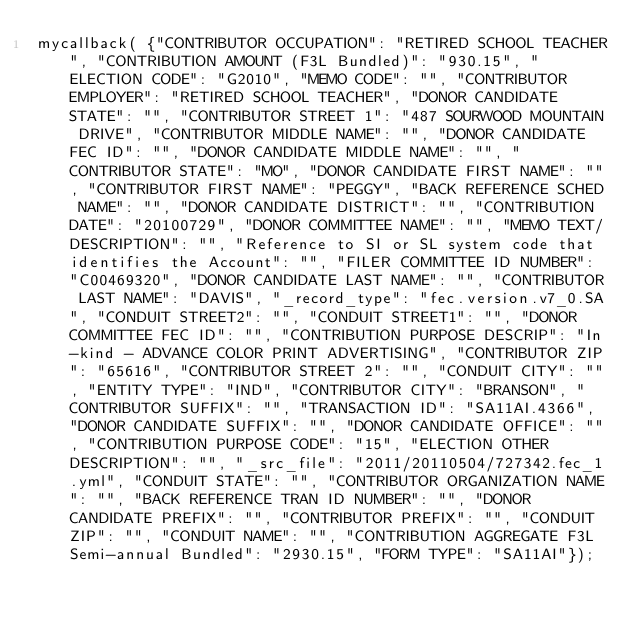<code> <loc_0><loc_0><loc_500><loc_500><_JavaScript_>mycallback( {"CONTRIBUTOR OCCUPATION": "RETIRED SCHOOL TEACHER", "CONTRIBUTION AMOUNT (F3L Bundled)": "930.15", "ELECTION CODE": "G2010", "MEMO CODE": "", "CONTRIBUTOR EMPLOYER": "RETIRED SCHOOL TEACHER", "DONOR CANDIDATE STATE": "", "CONTRIBUTOR STREET 1": "487 SOURWOOD MOUNTAIN DRIVE", "CONTRIBUTOR MIDDLE NAME": "", "DONOR CANDIDATE FEC ID": "", "DONOR CANDIDATE MIDDLE NAME": "", "CONTRIBUTOR STATE": "MO", "DONOR CANDIDATE FIRST NAME": "", "CONTRIBUTOR FIRST NAME": "PEGGY", "BACK REFERENCE SCHED NAME": "", "DONOR CANDIDATE DISTRICT": "", "CONTRIBUTION DATE": "20100729", "DONOR COMMITTEE NAME": "", "MEMO TEXT/DESCRIPTION": "", "Reference to SI or SL system code that identifies the Account": "", "FILER COMMITTEE ID NUMBER": "C00469320", "DONOR CANDIDATE LAST NAME": "", "CONTRIBUTOR LAST NAME": "DAVIS", "_record_type": "fec.version.v7_0.SA", "CONDUIT STREET2": "", "CONDUIT STREET1": "", "DONOR COMMITTEE FEC ID": "", "CONTRIBUTION PURPOSE DESCRIP": "In-kind - ADVANCE COLOR PRINT ADVERTISING", "CONTRIBUTOR ZIP": "65616", "CONTRIBUTOR STREET 2": "", "CONDUIT CITY": "", "ENTITY TYPE": "IND", "CONTRIBUTOR CITY": "BRANSON", "CONTRIBUTOR SUFFIX": "", "TRANSACTION ID": "SA11AI.4366", "DONOR CANDIDATE SUFFIX": "", "DONOR CANDIDATE OFFICE": "", "CONTRIBUTION PURPOSE CODE": "15", "ELECTION OTHER DESCRIPTION": "", "_src_file": "2011/20110504/727342.fec_1.yml", "CONDUIT STATE": "", "CONTRIBUTOR ORGANIZATION NAME": "", "BACK REFERENCE TRAN ID NUMBER": "", "DONOR CANDIDATE PREFIX": "", "CONTRIBUTOR PREFIX": "", "CONDUIT ZIP": "", "CONDUIT NAME": "", "CONTRIBUTION AGGREGATE F3L Semi-annual Bundled": "2930.15", "FORM TYPE": "SA11AI"});</code> 